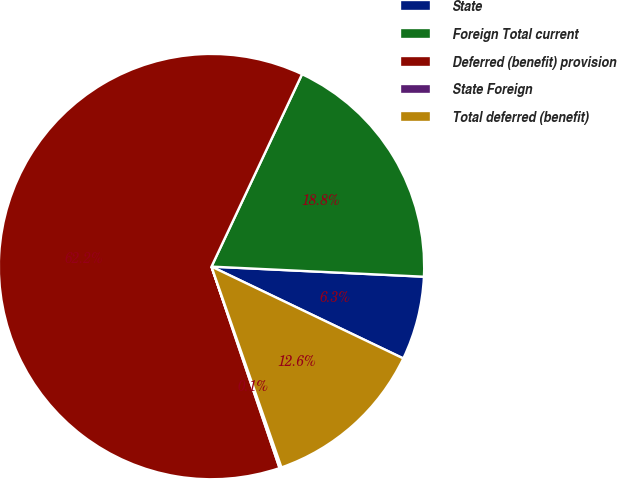<chart> <loc_0><loc_0><loc_500><loc_500><pie_chart><fcel>State<fcel>Foreign Total current<fcel>Deferred (benefit) provision<fcel>State Foreign<fcel>Total deferred (benefit)<nl><fcel>6.35%<fcel>18.76%<fcel>62.19%<fcel>0.15%<fcel>12.56%<nl></chart> 